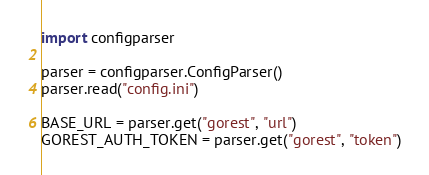<code> <loc_0><loc_0><loc_500><loc_500><_Python_>import configparser

parser = configparser.ConfigParser()
parser.read("config.ini")

BASE_URL = parser.get("gorest", "url")
GOREST_AUTH_TOKEN = parser.get("gorest", "token")
</code> 